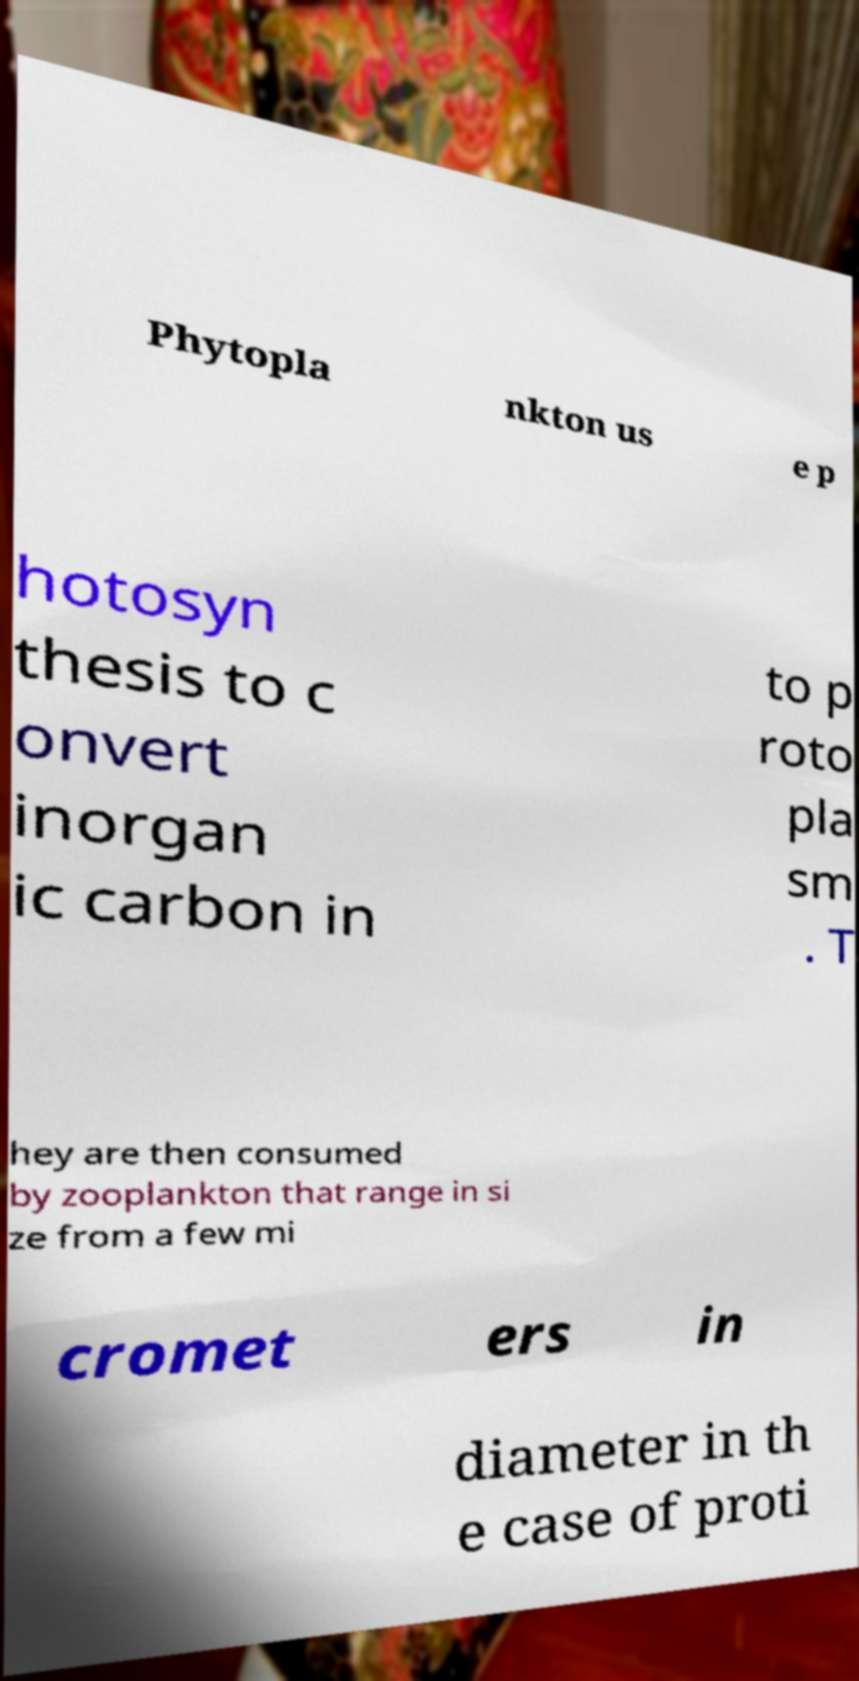Can you accurately transcribe the text from the provided image for me? Phytopla nkton us e p hotosyn thesis to c onvert inorgan ic carbon in to p roto pla sm . T hey are then consumed by zooplankton that range in si ze from a few mi cromet ers in diameter in th e case of proti 